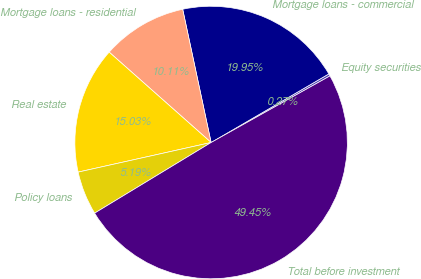Convert chart to OTSL. <chart><loc_0><loc_0><loc_500><loc_500><pie_chart><fcel>Equity securities<fcel>Mortgage loans - commercial<fcel>Mortgage loans - residential<fcel>Real estate<fcel>Policy loans<fcel>Total before investment<nl><fcel>0.27%<fcel>19.95%<fcel>10.11%<fcel>15.03%<fcel>5.19%<fcel>49.45%<nl></chart> 